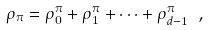Convert formula to latex. <formula><loc_0><loc_0><loc_500><loc_500>\rho _ { \pi } = \rho ^ { \pi } _ { 0 } + \rho ^ { \pi } _ { 1 } + \dots + \rho ^ { \pi } _ { d - 1 } \ ,</formula> 